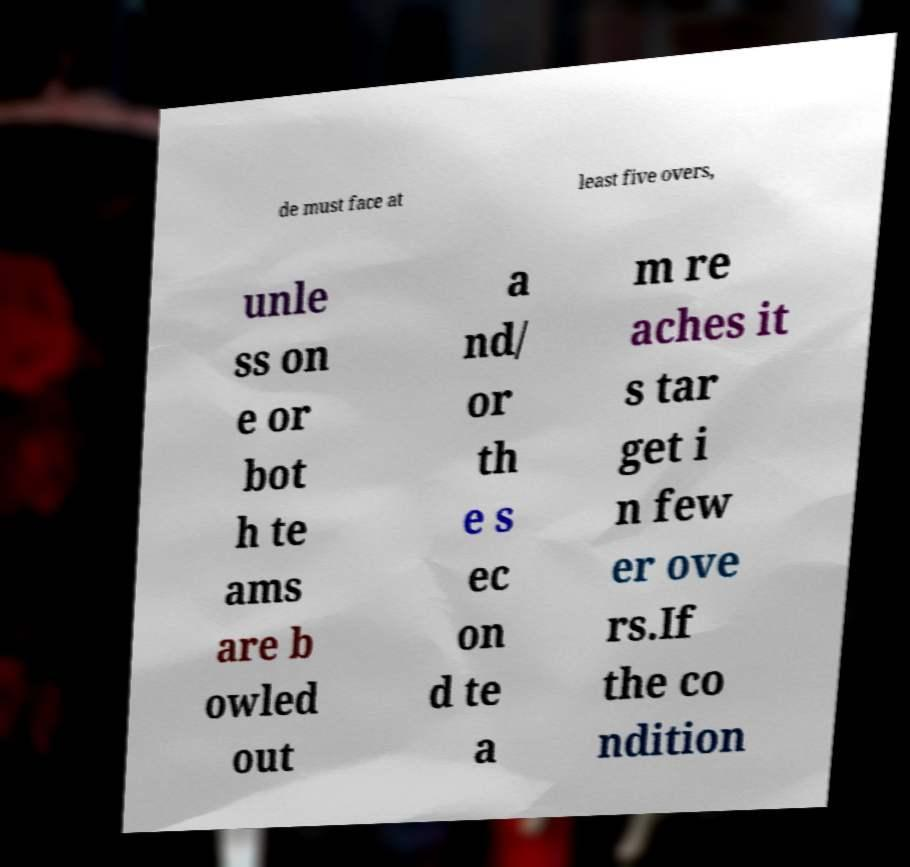Please read and relay the text visible in this image. What does it say? de must face at least five overs, unle ss on e or bot h te ams are b owled out a nd/ or th e s ec on d te a m re aches it s tar get i n few er ove rs.If the co ndition 